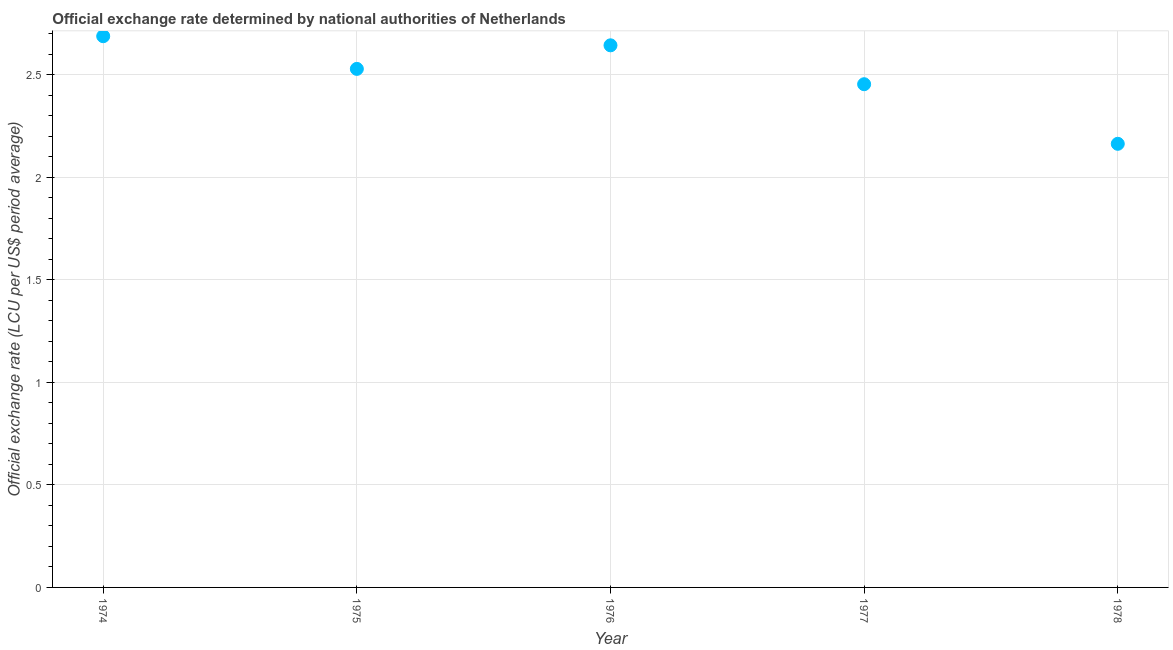What is the official exchange rate in 1975?
Offer a very short reply. 2.53. Across all years, what is the maximum official exchange rate?
Offer a very short reply. 2.69. Across all years, what is the minimum official exchange rate?
Ensure brevity in your answer.  2.16. In which year was the official exchange rate maximum?
Ensure brevity in your answer.  1974. In which year was the official exchange rate minimum?
Offer a terse response. 1978. What is the sum of the official exchange rate?
Your answer should be compact. 12.48. What is the difference between the official exchange rate in 1976 and 1977?
Offer a very short reply. 0.19. What is the average official exchange rate per year?
Your answer should be very brief. 2.5. What is the median official exchange rate?
Keep it short and to the point. 2.53. In how many years, is the official exchange rate greater than 2.1 ?
Make the answer very short. 5. Do a majority of the years between 1978 and 1974 (inclusive) have official exchange rate greater than 1.7 ?
Your answer should be compact. Yes. What is the ratio of the official exchange rate in 1974 to that in 1977?
Your answer should be compact. 1.1. Is the official exchange rate in 1977 less than that in 1978?
Offer a terse response. No. What is the difference between the highest and the second highest official exchange rate?
Offer a terse response. 0.04. Is the sum of the official exchange rate in 1974 and 1976 greater than the maximum official exchange rate across all years?
Your answer should be compact. Yes. What is the difference between the highest and the lowest official exchange rate?
Your answer should be very brief. 0.52. Are the values on the major ticks of Y-axis written in scientific E-notation?
Give a very brief answer. No. Does the graph contain any zero values?
Your response must be concise. No. What is the title of the graph?
Offer a very short reply. Official exchange rate determined by national authorities of Netherlands. What is the label or title of the X-axis?
Provide a short and direct response. Year. What is the label or title of the Y-axis?
Provide a short and direct response. Official exchange rate (LCU per US$ period average). What is the Official exchange rate (LCU per US$ period average) in 1974?
Provide a succinct answer. 2.69. What is the Official exchange rate (LCU per US$ period average) in 1975?
Make the answer very short. 2.53. What is the Official exchange rate (LCU per US$ period average) in 1976?
Provide a short and direct response. 2.64. What is the Official exchange rate (LCU per US$ period average) in 1977?
Keep it short and to the point. 2.45. What is the Official exchange rate (LCU per US$ period average) in 1978?
Offer a terse response. 2.16. What is the difference between the Official exchange rate (LCU per US$ period average) in 1974 and 1975?
Make the answer very short. 0.16. What is the difference between the Official exchange rate (LCU per US$ period average) in 1974 and 1976?
Make the answer very short. 0.04. What is the difference between the Official exchange rate (LCU per US$ period average) in 1974 and 1977?
Your answer should be very brief. 0.23. What is the difference between the Official exchange rate (LCU per US$ period average) in 1974 and 1978?
Your answer should be very brief. 0.52. What is the difference between the Official exchange rate (LCU per US$ period average) in 1975 and 1976?
Provide a short and direct response. -0.11. What is the difference between the Official exchange rate (LCU per US$ period average) in 1975 and 1977?
Offer a terse response. 0.07. What is the difference between the Official exchange rate (LCU per US$ period average) in 1975 and 1978?
Ensure brevity in your answer.  0.37. What is the difference between the Official exchange rate (LCU per US$ period average) in 1976 and 1977?
Provide a short and direct response. 0.19. What is the difference between the Official exchange rate (LCU per US$ period average) in 1976 and 1978?
Your answer should be very brief. 0.48. What is the difference between the Official exchange rate (LCU per US$ period average) in 1977 and 1978?
Your response must be concise. 0.29. What is the ratio of the Official exchange rate (LCU per US$ period average) in 1974 to that in 1975?
Offer a terse response. 1.06. What is the ratio of the Official exchange rate (LCU per US$ period average) in 1974 to that in 1977?
Keep it short and to the point. 1.09. What is the ratio of the Official exchange rate (LCU per US$ period average) in 1974 to that in 1978?
Give a very brief answer. 1.24. What is the ratio of the Official exchange rate (LCU per US$ period average) in 1975 to that in 1978?
Give a very brief answer. 1.17. What is the ratio of the Official exchange rate (LCU per US$ period average) in 1976 to that in 1977?
Give a very brief answer. 1.08. What is the ratio of the Official exchange rate (LCU per US$ period average) in 1976 to that in 1978?
Give a very brief answer. 1.22. What is the ratio of the Official exchange rate (LCU per US$ period average) in 1977 to that in 1978?
Your response must be concise. 1.13. 